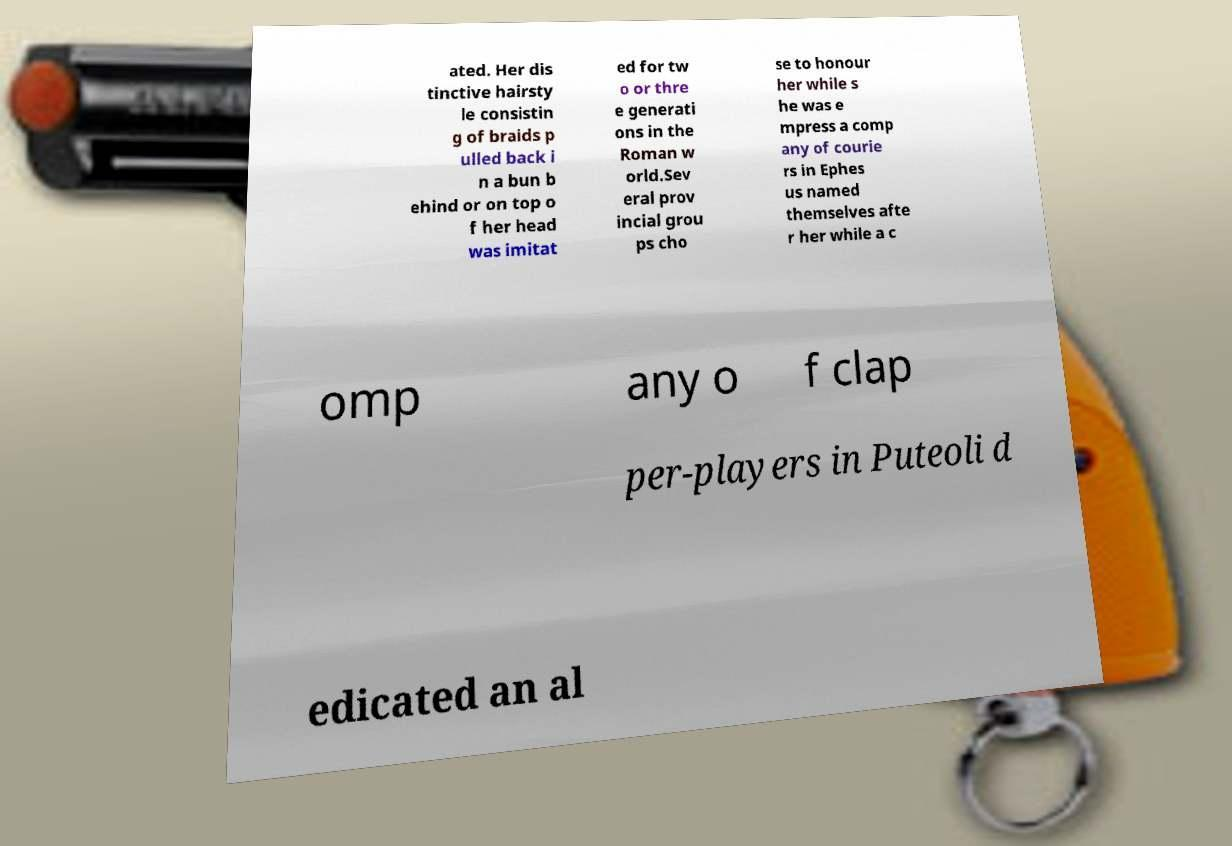Can you read and provide the text displayed in the image?This photo seems to have some interesting text. Can you extract and type it out for me? ated. Her dis tinctive hairsty le consistin g of braids p ulled back i n a bun b ehind or on top o f her head was imitat ed for tw o or thre e generati ons in the Roman w orld.Sev eral prov incial grou ps cho se to honour her while s he was e mpress a comp any of courie rs in Ephes us named themselves afte r her while a c omp any o f clap per-players in Puteoli d edicated an al 